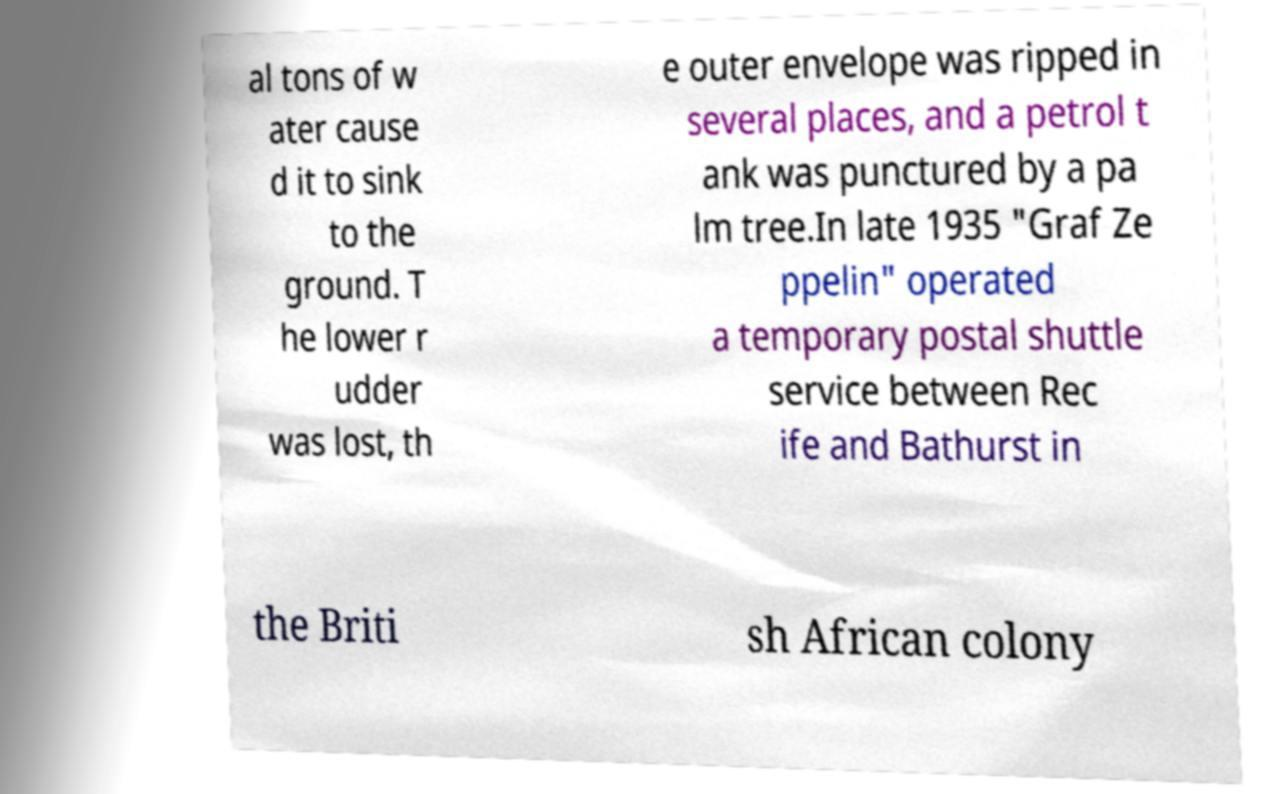What messages or text are displayed in this image? I need them in a readable, typed format. al tons of w ater cause d it to sink to the ground. T he lower r udder was lost, th e outer envelope was ripped in several places, and a petrol t ank was punctured by a pa lm tree.In late 1935 "Graf Ze ppelin" operated a temporary postal shuttle service between Rec ife and Bathurst in the Briti sh African colony 